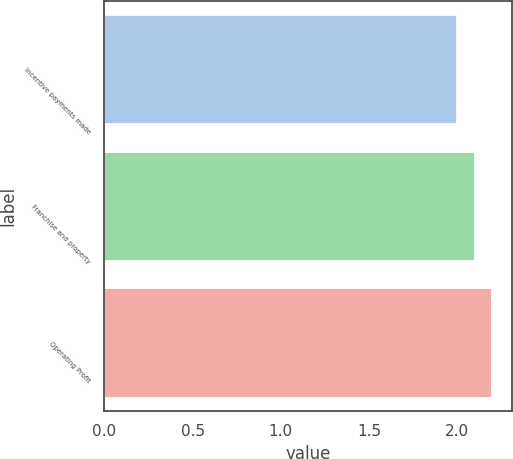Convert chart. <chart><loc_0><loc_0><loc_500><loc_500><bar_chart><fcel>Incentive payments made<fcel>Franchise and property<fcel>Operating Profit<nl><fcel>2<fcel>2.1<fcel>2.2<nl></chart> 